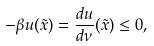Convert formula to latex. <formula><loc_0><loc_0><loc_500><loc_500>{ - \beta u ( \tilde { x } ) = \frac { d u } { d \nu } ( \tilde { x } ) \leq 0 , }</formula> 